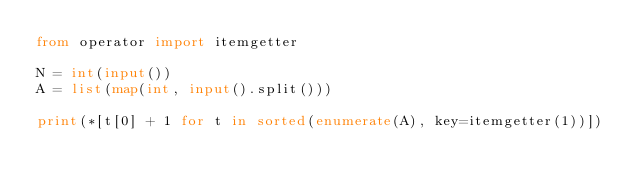Convert code to text. <code><loc_0><loc_0><loc_500><loc_500><_Python_>from operator import itemgetter

N = int(input())
A = list(map(int, input().split()))

print(*[t[0] + 1 for t in sorted(enumerate(A), key=itemgetter(1))])</code> 